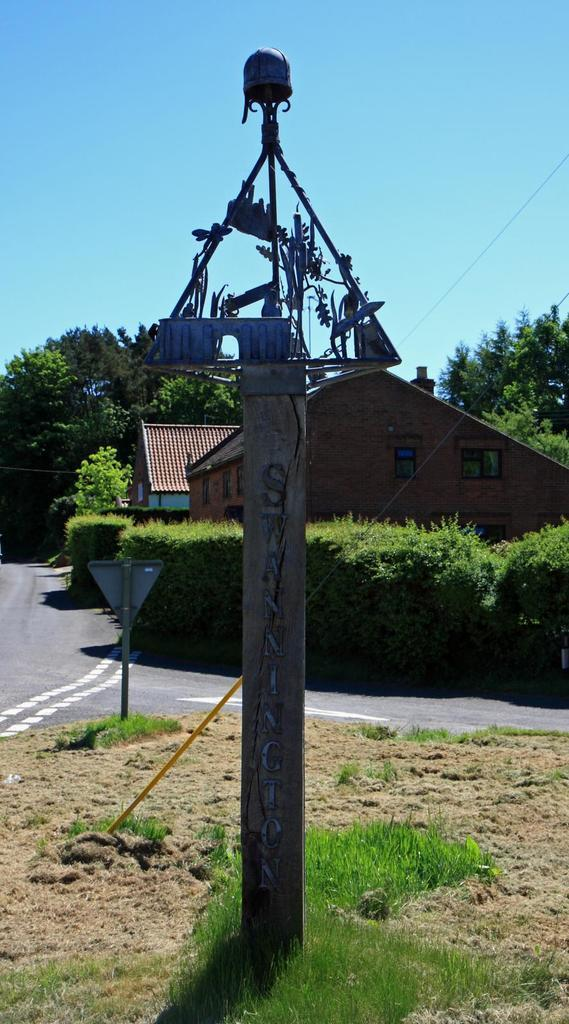What is the main object in the image? There is a pole in the image. What can be seen behind the pole? There are trees and houses behind the pole. What is attached to the pole? There is a cable visible in the image. What is visible in the background of the image? The sky is visible in the image. What type of sticks are being used to write a fictional story in the image? There are no sticks or fictional stories present in the image. 